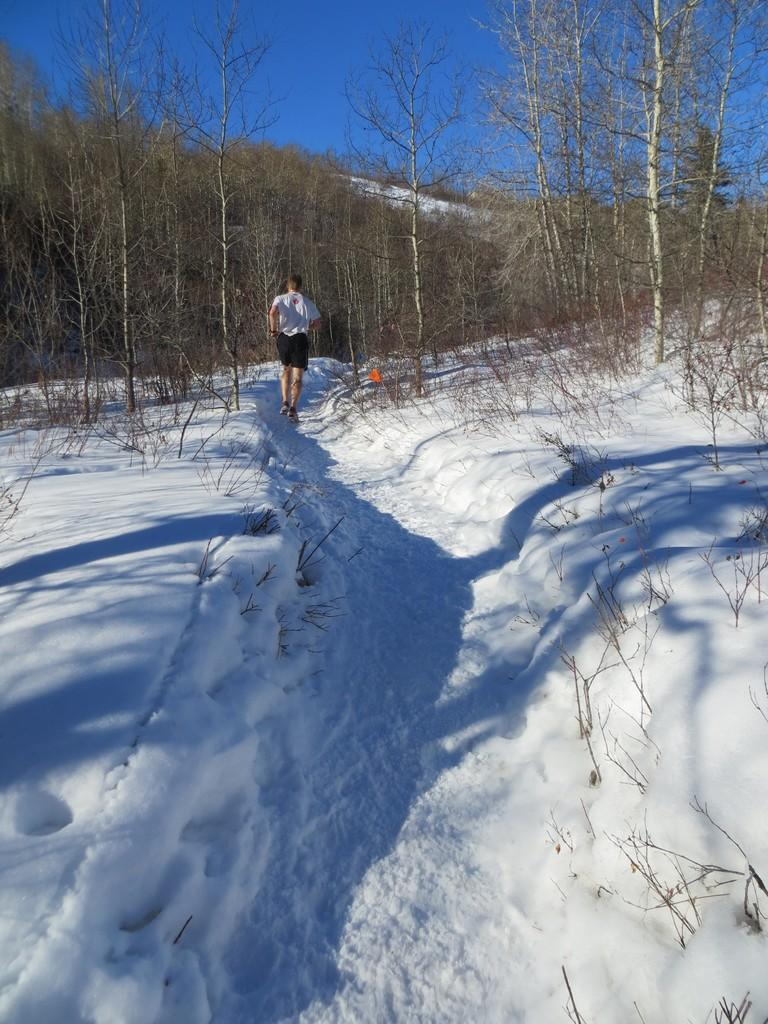What is the person in the image doing? The person is running in the image. What is the condition of the ground in the image? The ground is covered with snow. What type of vegetation can be seen in the image? Dry plants are visible in the image. What natural feature is present in the image? There is a mountain in the image. What is visible in the sky in the image? The sky is visible in the image. How many people are in the crowd in the image? There is no crowd present in the image; it only features a person running. What type of foot is visible in the image? There is no specific foot visible in the image; it only shows a person running. 